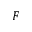<formula> <loc_0><loc_0><loc_500><loc_500>F</formula> 